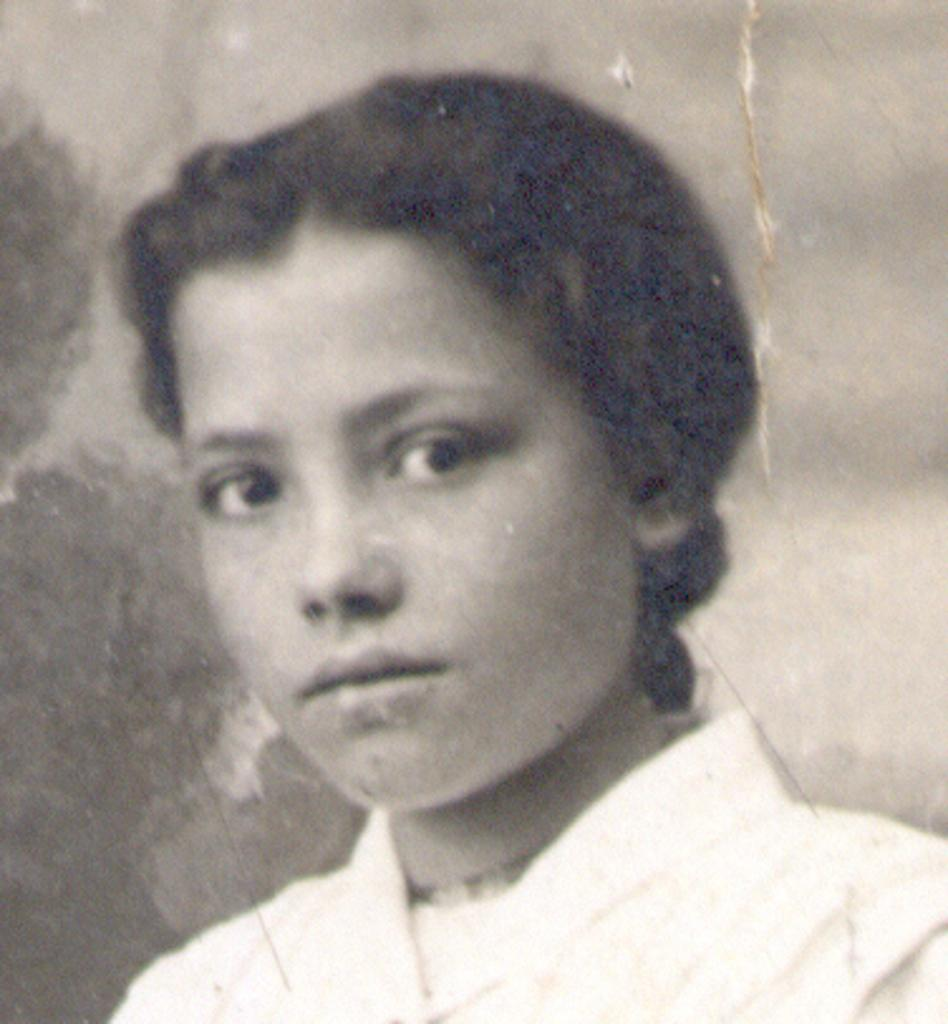What is the color scheme of the image? The image is black and white. Who or what is the main subject in the image? There is a person in the image. What is the person wearing? The person is wearing a dress. What is the person's facial expression in the image? The person is smiling. How would you describe the background of the image? The background is blurred. Reasoning: Let' Let's think step by step in order to produce the conversation. We start by identifying the color scheme of the image, which is black and white. Then, we focus on the main subject, which is a person. We describe the person's clothing and facial expression, as well as the background of the image. Each question is designed to elicit a specific detail about the image that is known from the provided facts. Absurd Question/Answer: What type of apparel is the person wearing on their side in the image? There is no mention of any specific apparel on the person's side in the image, as the focus is on the person wearing a dress. What type of answer can be seen written on the person's side in the image? There is no answer written on the person's side in the image, as the focus is on the person wearing a dress and the image is black and white. 